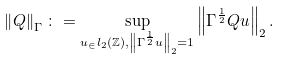<formula> <loc_0><loc_0><loc_500><loc_500>\left \| Q \right \| _ { \Gamma } \colon = \sup _ { u _ { \in } l _ { 2 } ( \mathbb { Z } ) , \left \| \Gamma ^ { \frac { 1 } { 2 } } u \right \| _ { 2 } = 1 } \left \| \Gamma ^ { \frac { 1 } { 2 } } Q u \right \| _ { 2 } .</formula> 